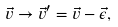<formula> <loc_0><loc_0><loc_500><loc_500>\vec { v } \to \vec { v } ^ { \prime } = \vec { v } - \vec { \epsilon } ,</formula> 